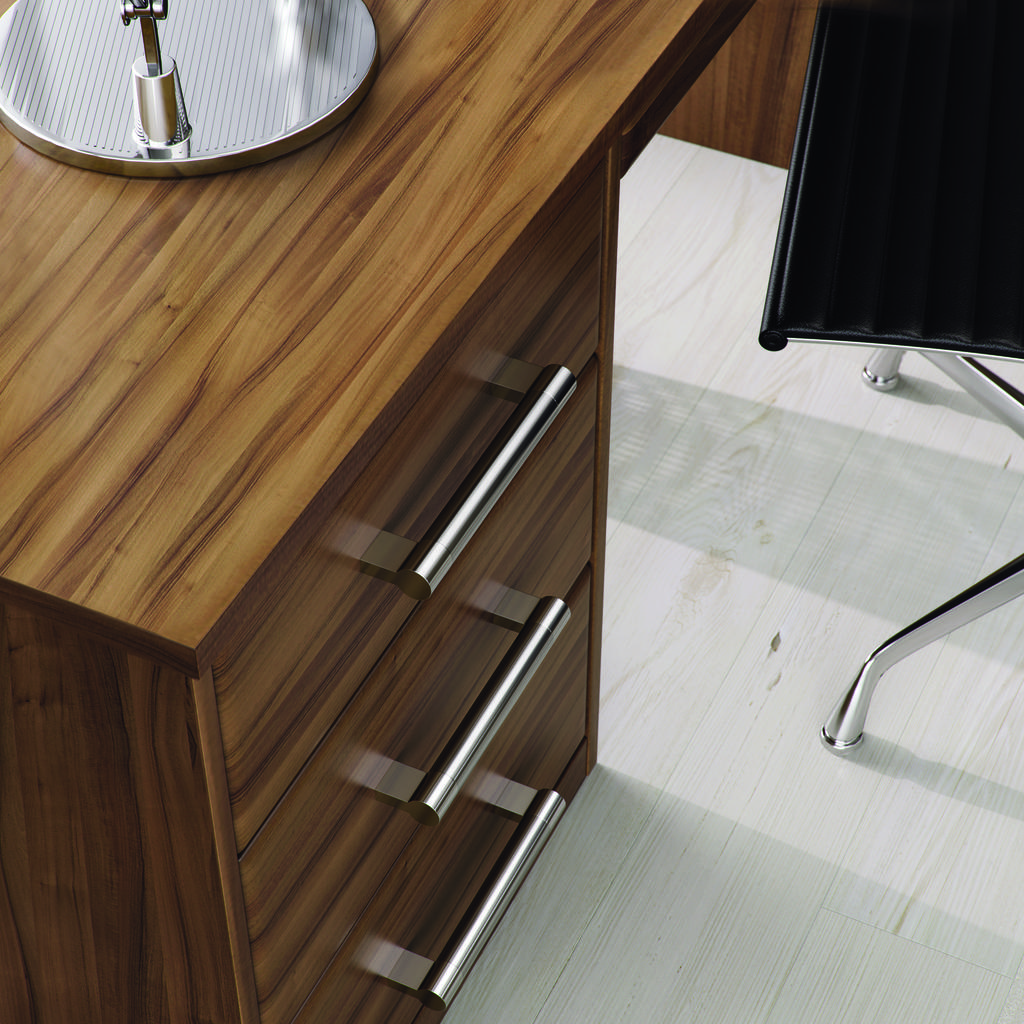What type of furniture is present in the image? There is a table and a chair in the image. What feature does the table have? The table has drawers. What is the chair's position in relation to the table? The chair is in front of the table. What material is used for the floor in the image? The floor is made of white wood. What type of ear is visible on the table in the image? There is no ear present on the table in the image. What news event is being discussed at the table in the image? There is no indication of a news event being discussed in the image. 